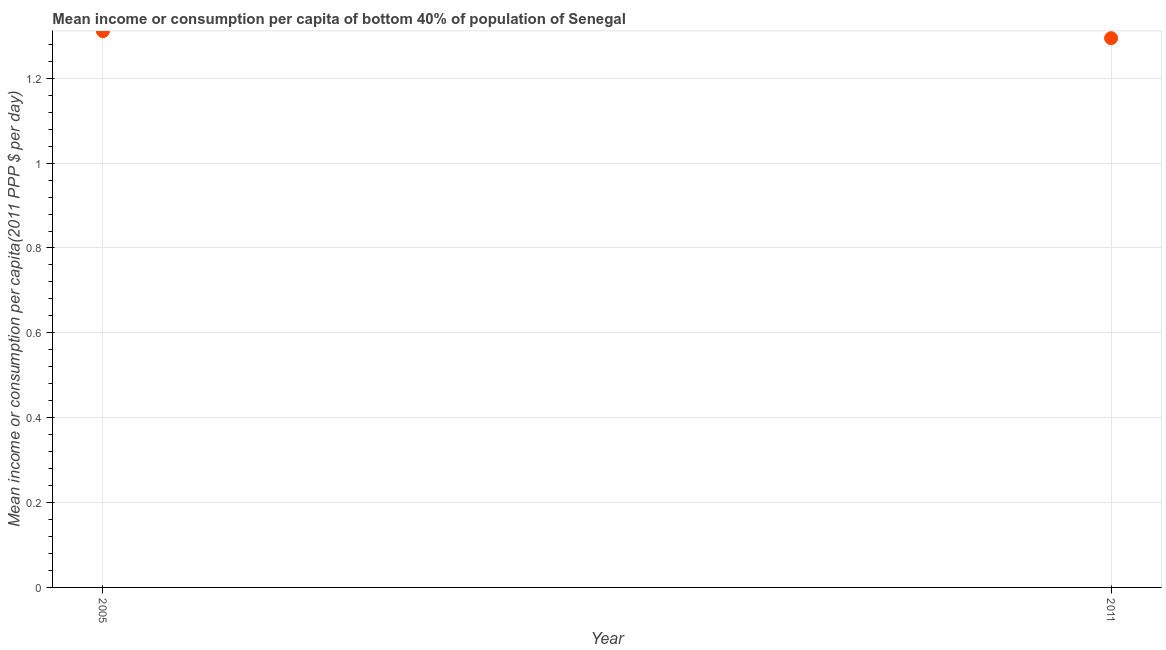What is the mean income or consumption in 2011?
Your response must be concise. 1.29. Across all years, what is the maximum mean income or consumption?
Your answer should be compact. 1.31. Across all years, what is the minimum mean income or consumption?
Your answer should be very brief. 1.29. In which year was the mean income or consumption maximum?
Offer a terse response. 2005. What is the sum of the mean income or consumption?
Ensure brevity in your answer.  2.61. What is the difference between the mean income or consumption in 2005 and 2011?
Offer a very short reply. 0.02. What is the average mean income or consumption per year?
Give a very brief answer. 1.3. What is the median mean income or consumption?
Offer a terse response. 1.3. What is the ratio of the mean income or consumption in 2005 to that in 2011?
Keep it short and to the point. 1.01. Does the mean income or consumption monotonically increase over the years?
Make the answer very short. No. How many years are there in the graph?
Your answer should be compact. 2. What is the title of the graph?
Offer a very short reply. Mean income or consumption per capita of bottom 40% of population of Senegal. What is the label or title of the Y-axis?
Your answer should be compact. Mean income or consumption per capita(2011 PPP $ per day). What is the Mean income or consumption per capita(2011 PPP $ per day) in 2005?
Your answer should be compact. 1.31. What is the Mean income or consumption per capita(2011 PPP $ per day) in 2011?
Your response must be concise. 1.29. What is the difference between the Mean income or consumption per capita(2011 PPP $ per day) in 2005 and 2011?
Your answer should be very brief. 0.02. What is the ratio of the Mean income or consumption per capita(2011 PPP $ per day) in 2005 to that in 2011?
Keep it short and to the point. 1.01. 